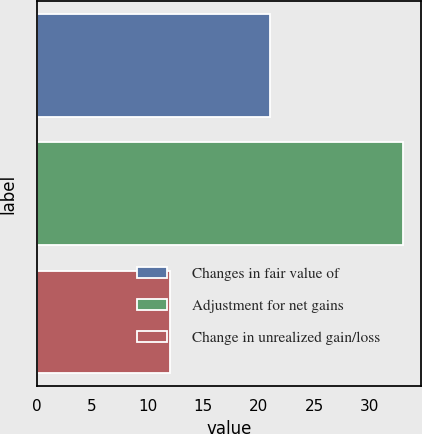<chart> <loc_0><loc_0><loc_500><loc_500><bar_chart><fcel>Changes in fair value of<fcel>Adjustment for net gains<fcel>Change in unrealized gain/loss<nl><fcel>21<fcel>33<fcel>12<nl></chart> 